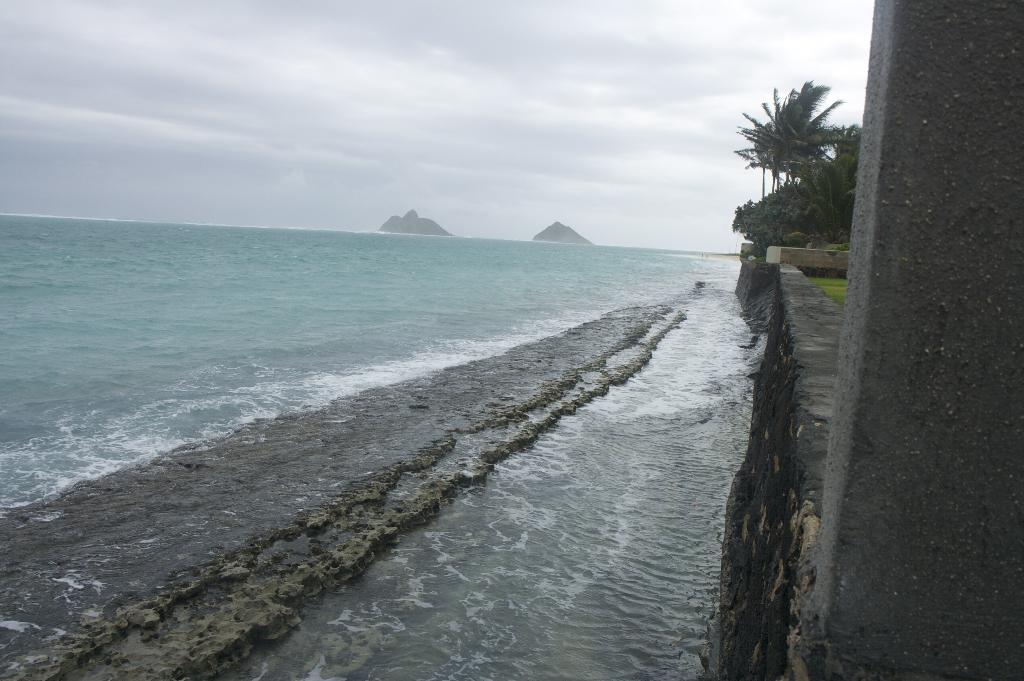What type of natural environment is depicted in the image? There is a beach in the image, which suggests a coastal environment. What other geographical features can be seen in the image? Mountains are visible in the image. How would you describe the weather in the image? The sky is cloudy in the image, which might indicate overcast or potentially rainy weather. What structures are present on the right side of the image? There is a pillar, a wall, and trees on the right side of the image. What type of vegetation is present on the right side of the image? There is grass and trees on the right side of the image. What degree does the person in the image have? There is no person present in the image, so it is not possible to determine their degree. Is there a volcano visible in the image? No, there is no volcano present in the image. 